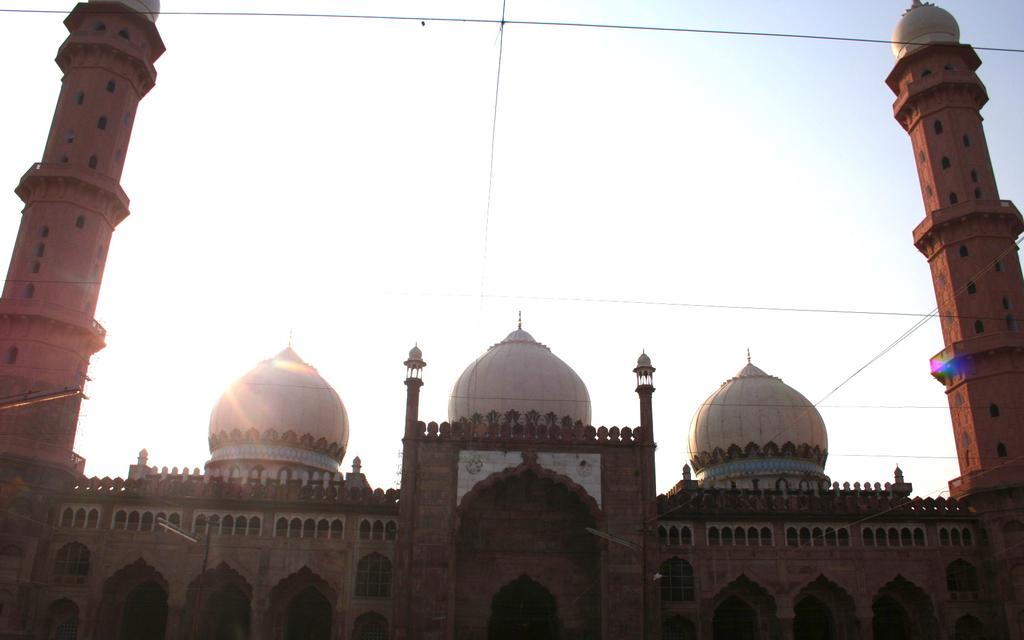What is the main structure in the center of the image? There is a palace in the center of the image. What architectural features can be seen in the image? There are pillars visible in the image. What is present at the top of the image? Wires and the sky are visible at the top of the image. How many balls are rolling on the grass in the image? There is no grass or balls present in the image. 